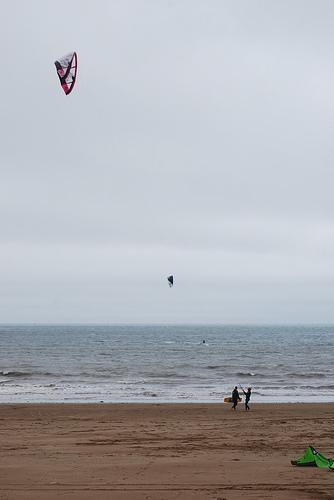How many people are there?
Give a very brief answer. 2. How many people are in the photograph?
Give a very brief answer. 2. 